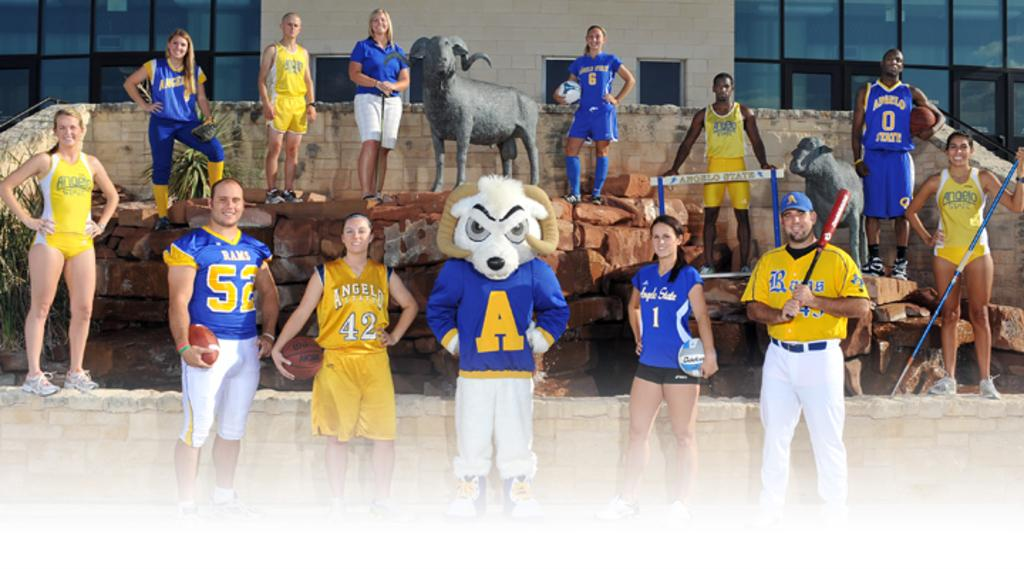<image>
Write a terse but informative summary of the picture. A group of atheletes pose for the camera wearring tops bearing the name Rams on them 